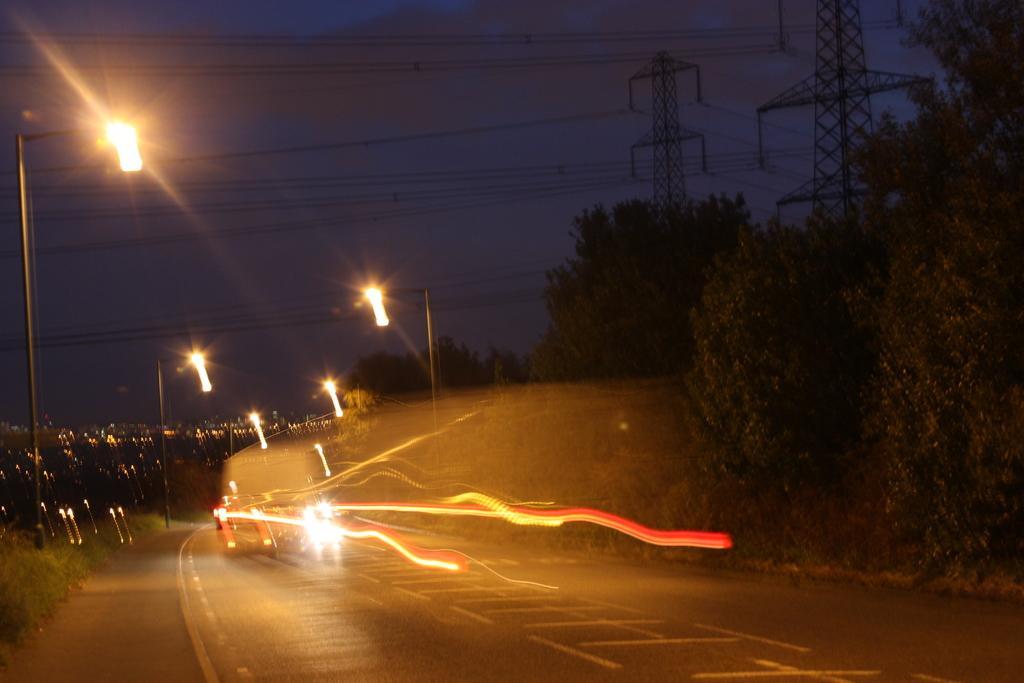In one or two sentences, can you explain what this image depicts? This picture is taken during night, in the picture here are some vehicles, beside the road street light poles, there are some lights attached, at the top there is the sky and power line cables, power pole visible, in front of it there are some trees on the right side. 